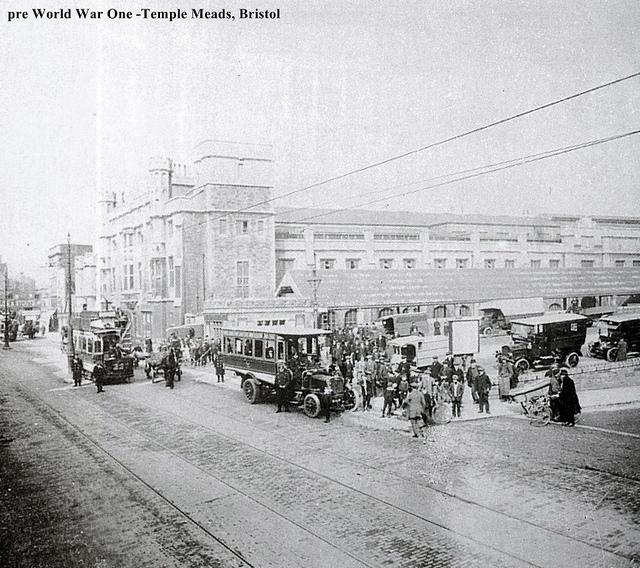What vehicles are in the pic?
Be succinct. Trolleys. What color is the photo?
Concise answer only. Black and white. Was this photo taken in the 21st century?
Be succinct. No. 